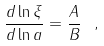Convert formula to latex. <formula><loc_0><loc_0><loc_500><loc_500>\frac { d \ln \xi } { d \ln a } = \frac { A } { B } \ ,</formula> 